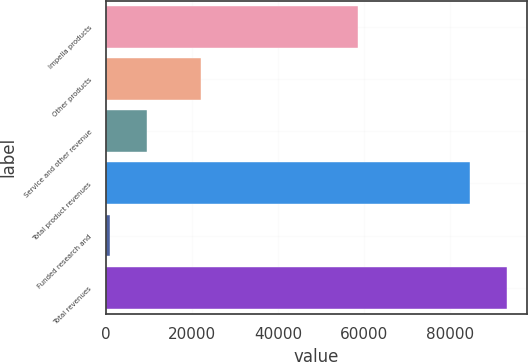Convert chart to OTSL. <chart><loc_0><loc_0><loc_500><loc_500><bar_chart><fcel>Impella products<fcel>Other products<fcel>Service and other revenue<fcel>Total product revenues<fcel>Funded research and<fcel>Total revenues<nl><fcel>58582<fcel>22102<fcel>9424.5<fcel>84765<fcel>948<fcel>93241.5<nl></chart> 